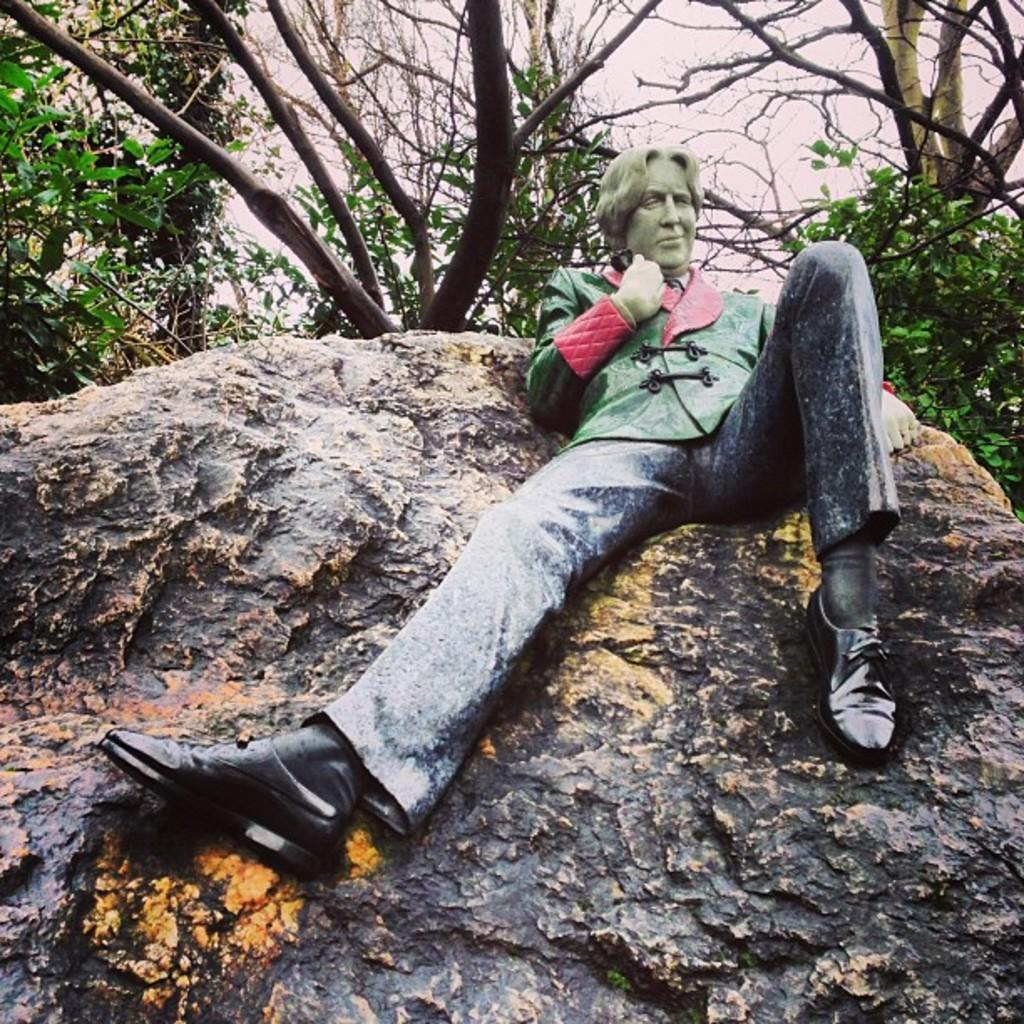What is the main subject of the image? There is a person in the image. What is the person doing in the image? The person is sitting on a rock. What can be seen in the background of the image? There are trees in the background of the image. What type of value can be seen fluctuating in the image? There is no value or financial instrument present in the image; it features a person sitting on a rock with trees in the background. What is the slope of the rock the person is sitting on in the image? The facts provided do not give information about the slope of the rock, so it cannot be determined from the image. 